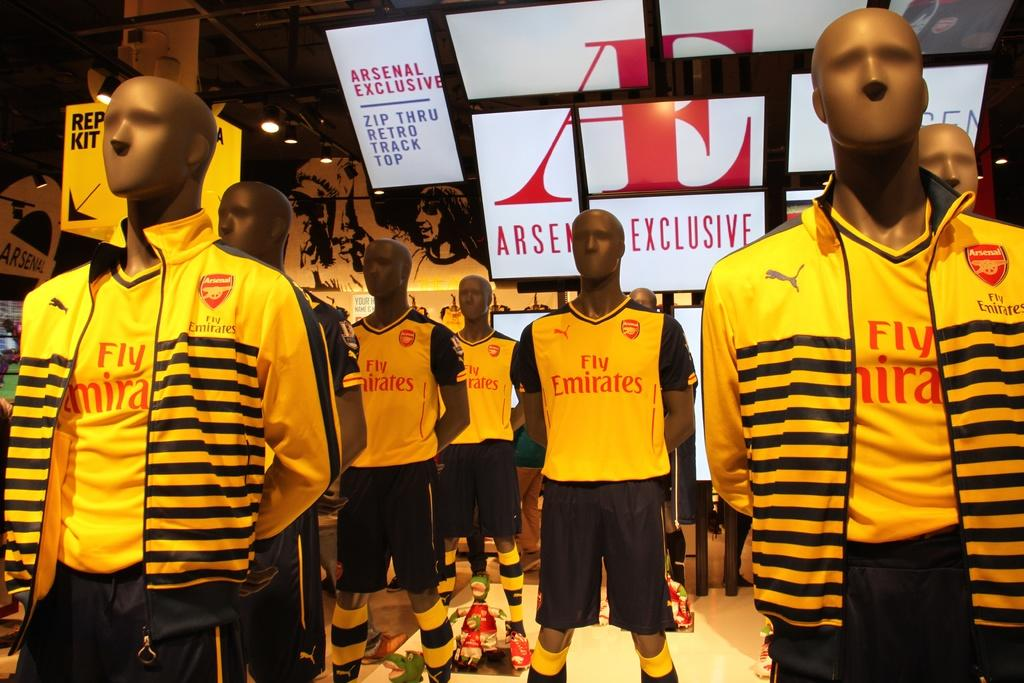<image>
Present a compact description of the photo's key features. Some mannequins wearing yellow shirts which read Fly Emirates. 